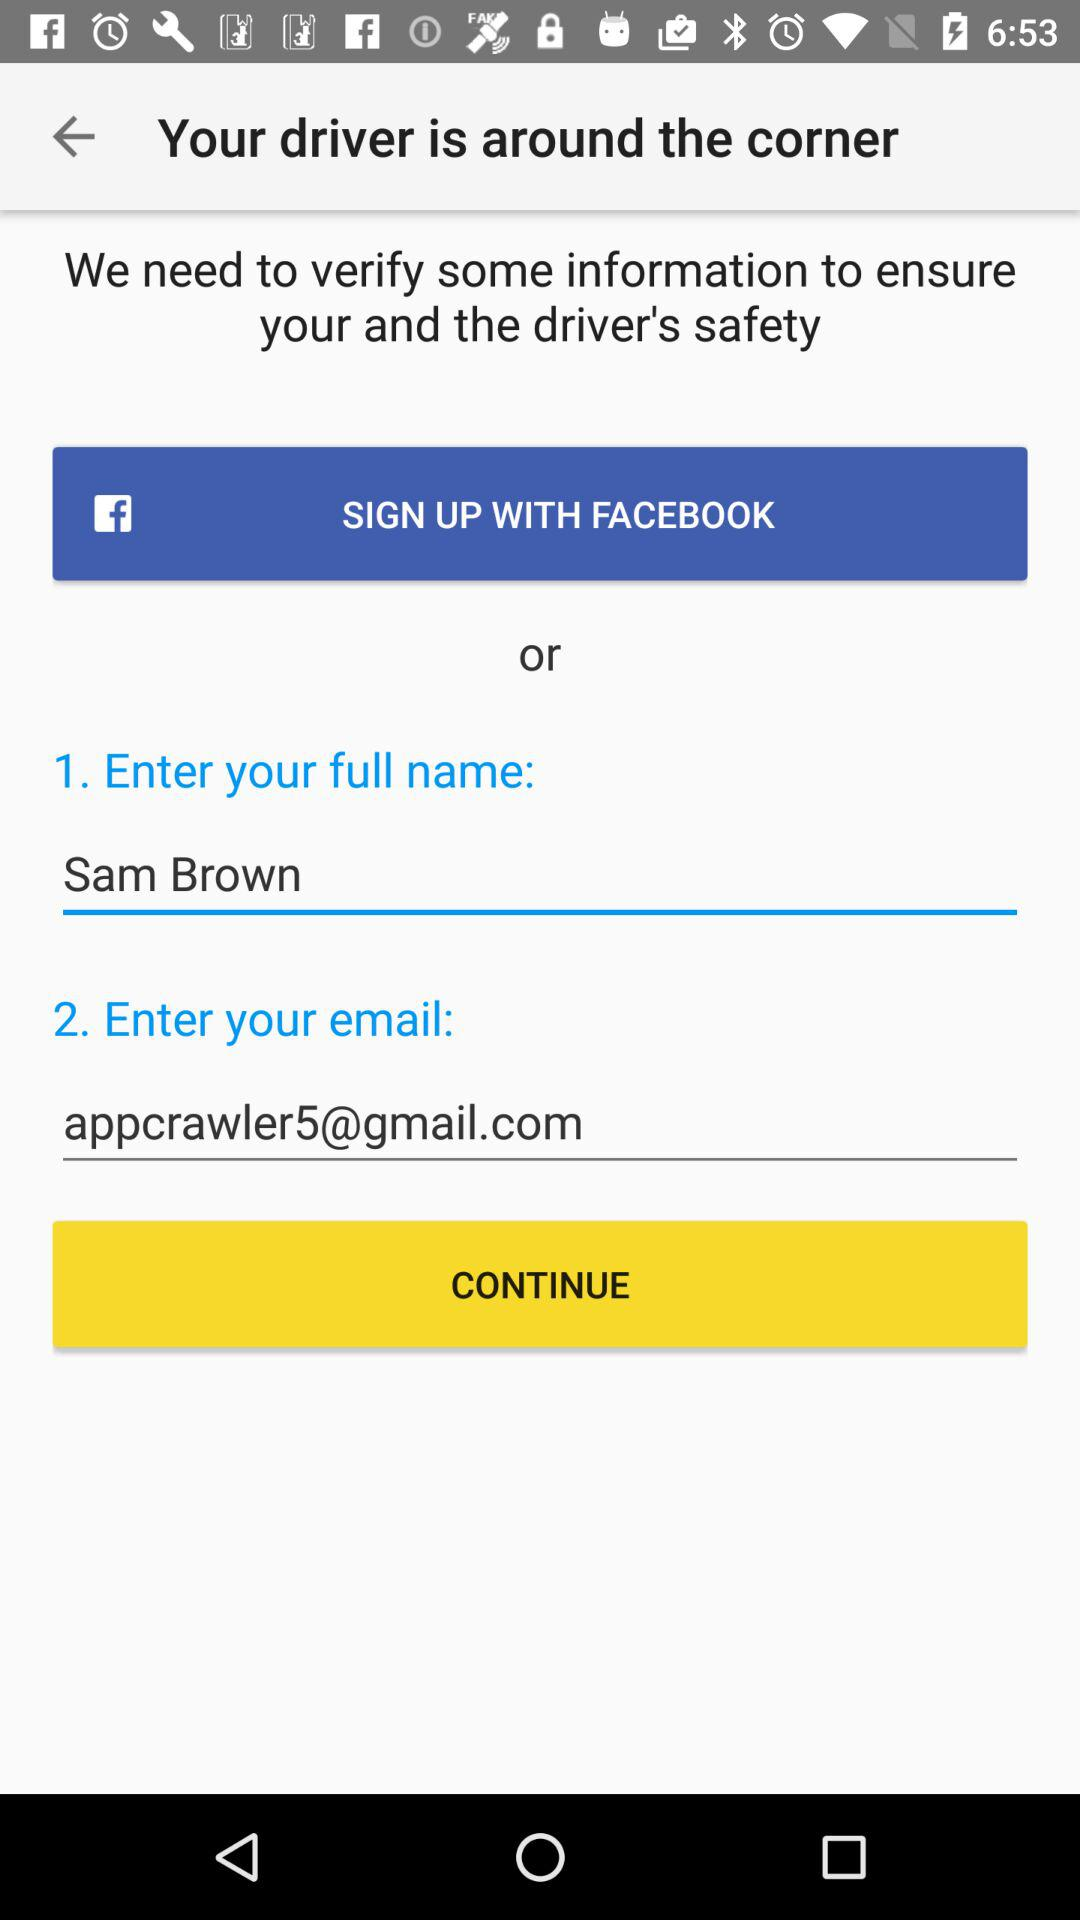What is the email address? The email address is appcrawler5@gmail.com. 